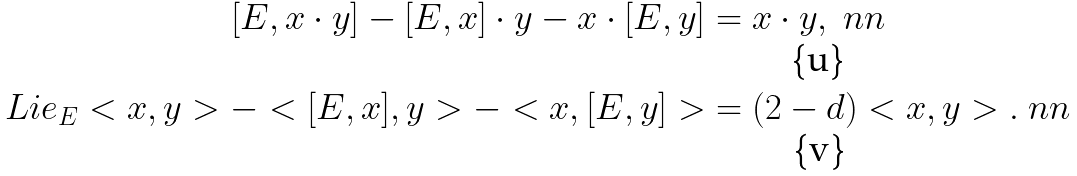<formula> <loc_0><loc_0><loc_500><loc_500>[ E , x \cdot y ] - [ E , x ] \cdot y - x \cdot [ E , y ] & = x \cdot y , \ n n \\ L i e _ { E } < x , y > - < [ E , x ] , y > - < x , [ E , y ] > & = ( 2 - d ) < x , y > . \ n n</formula> 